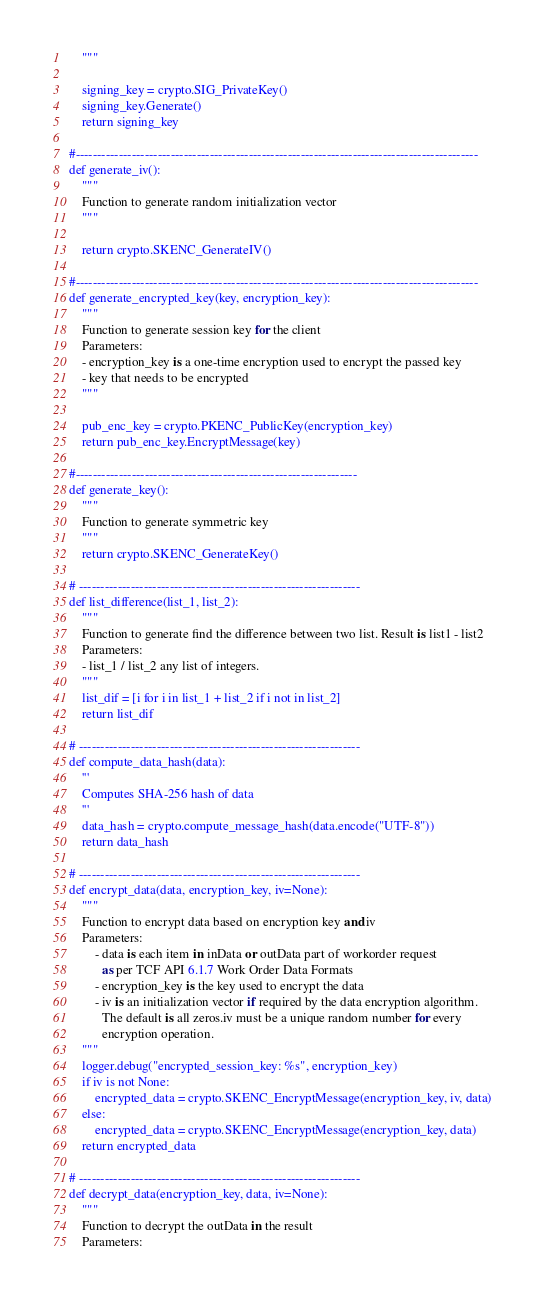<code> <loc_0><loc_0><loc_500><loc_500><_Python_>    """

    signing_key = crypto.SIG_PrivateKey()
    signing_key.Generate()
    return signing_key

#---------------------------------------------------------------------------------------------
def generate_iv():
    """
    Function to generate random initialization vector
    """

    return crypto.SKENC_GenerateIV()

#---------------------------------------------------------------------------------------------
def generate_encrypted_key(key, encryption_key):
    """
    Function to generate session key for the client
    Parameters:
    - encryption_key is a one-time encryption used to encrypt the passed key
    - key that needs to be encrypted
    """

    pub_enc_key = crypto.PKENC_PublicKey(encryption_key)
    return pub_enc_key.EncryptMessage(key)

#-----------------------------------------------------------------
def generate_key():
    """
    Function to generate symmetric key
    """
    return crypto.SKENC_GenerateKey()

# -----------------------------------------------------------------
def list_difference(list_1, list_2):
    """
    Function to generate find the difference between two list. Result is list1 - list2
    Parameters:
    - list_1 / list_2 any list of integers.
    """
    list_dif = [i for i in list_1 + list_2 if i not in list_2]
    return list_dif

# -----------------------------------------------------------------
def compute_data_hash(data):
    '''
    Computes SHA-256 hash of data
    '''
    data_hash = crypto.compute_message_hash(data.encode("UTF-8"))
    return data_hash

# -----------------------------------------------------------------
def encrypt_data(data, encryption_key, iv=None):
    """
    Function to encrypt data based on encryption key and iv
    Parameters:
        - data is each item in inData or outData part of workorder request
          as per TCF API 6.1.7 Work Order Data Formats
        - encryption_key is the key used to encrypt the data
        - iv is an initialization vector if required by the data encryption algorithm.
          The default is all zeros.iv must be a unique random number for every
          encryption operation.
    """
    logger.debug("encrypted_session_key: %s", encryption_key)
    if iv is not None:
        encrypted_data = crypto.SKENC_EncryptMessage(encryption_key, iv, data)
    else:
        encrypted_data = crypto.SKENC_EncryptMessage(encryption_key, data)
    return encrypted_data

# -----------------------------------------------------------------
def decrypt_data(encryption_key, data, iv=None):
    """
    Function to decrypt the outData in the result
    Parameters:</code> 